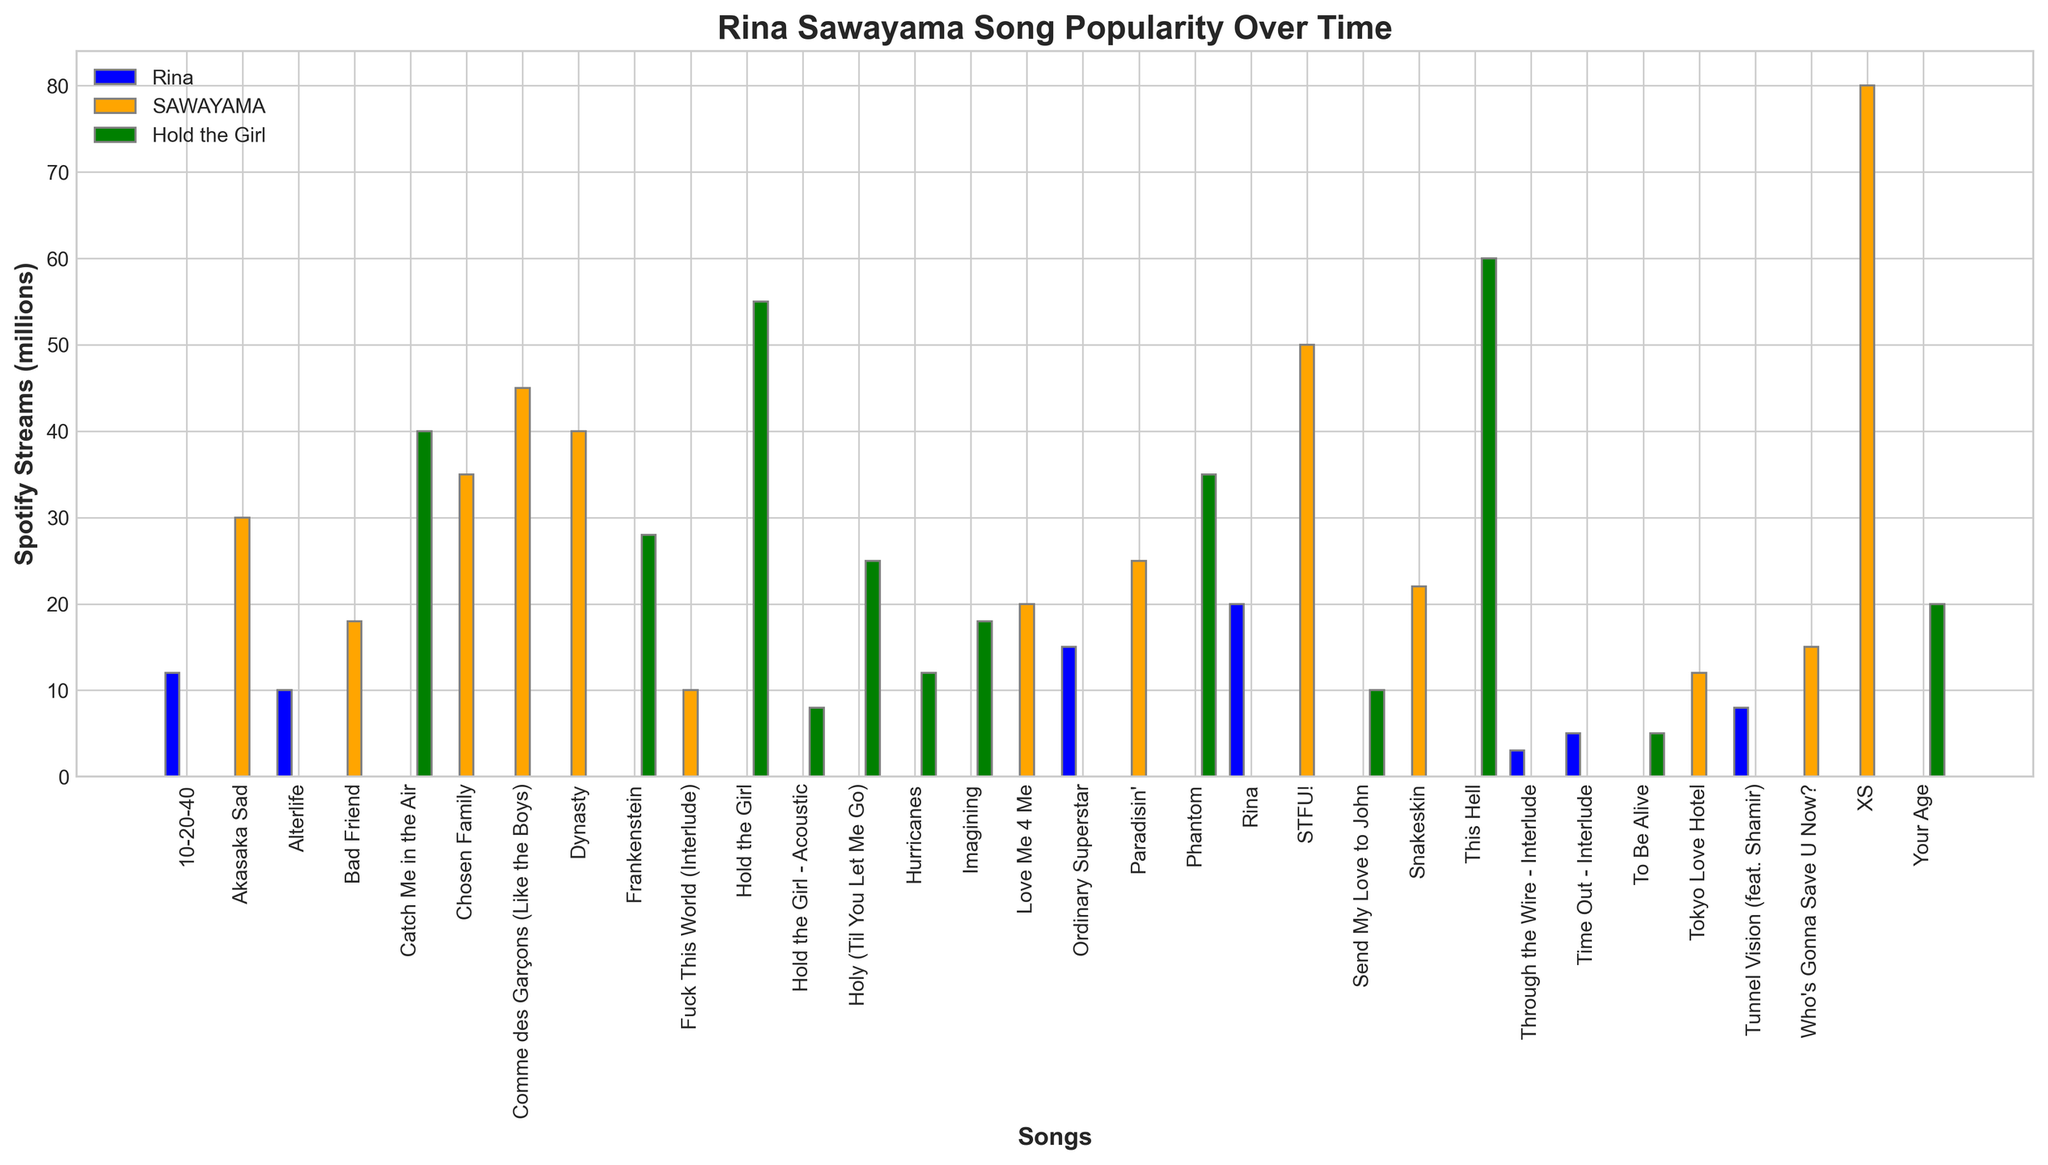How many streams did the song with the highest streams from the album "SAWAYAMA" get? First, look at the bars labeled "SAWAYAMA" and identify the tallest one. The tallest bar corresponds to the song "XS," which has 80 million streams.
Answer: 80 million Which album has the song with the least recorded streams? Identify the shortest bar across all three albums. The shortest bar is from the album "Rina" for the song "Through the Wire - Interlude" with 3 million streams.
Answer: Rina Which song has more streams: "Catch Me in the Air" or "Chosen Family"? Compare the bars for "Catch Me in the Air" (Hold the Girl) and "Chosen Family" (SAWAYAMA). "Catch Me in the Air" has 40 million streams, while "Chosen Family" has 35 million streams. Therefore, "Catch Me in the Air" has more streams.
Answer: Catch Me in the Air What is the total number of streams for all songs in the album "Rina"? Sum the heights of all bars labeled "Rina": 20 + 15 + 12 + 10 + 8 + 5 + 3 = 73 million streams.
Answer: 73 million What is the most streamed song in the entire dataset? Identify the tallest bar in the entire plot. The tallest bar corresponds to the song "XS" in the album "SAWAYAMA" with 80 million streams.
Answer: XS How many more streams does "This Hell" (Hold the Girl) have compared to "Dynasty" (SAWAYAMA)? The height of the bar for "This Hell" is 60 million streams, and for "Dynasty" it is 40 million streams. Subtract the two: 60 - 40 = 20 million streams.
Answer: 20 million Which song in the album "Rina" has the second-highest number of streams? Among the "Rina" bars, the one with the second-highest height corresponds to "Ordinary Superstar" with 15 million streams.
Answer: Ordinary Superstar What is the average number of streams for songs in the album "Hold the Girl"? Sum the heights of all bars for "Hold the Girl" and divide by the number of songs: (55 + 60 + 40 + 35 + 25 + 20 + 18 + 28 + 12 + 10 + 8 + 5) / 12 = 316 / 12 ≈ 26.33 million streams.
Answer: Approximately 26.33 million Which album contains the song "STFU!" and how many streams does it have? Find the bar labeled "STFU!" which is under the album "SAWAYAMA" and note its height, which is 50 million streams.
Answer: SAWAYAMA, 50 million Between albums "Rina" and "Hold the Girl," which has the song with the highest number of streams? Compare the highest bars for both albums: "Rina" (20 million) vs. "Hold the Girl" (60 million). The album "Hold the Girl" has the song with the highest streams.
Answer: Hold the Girl 